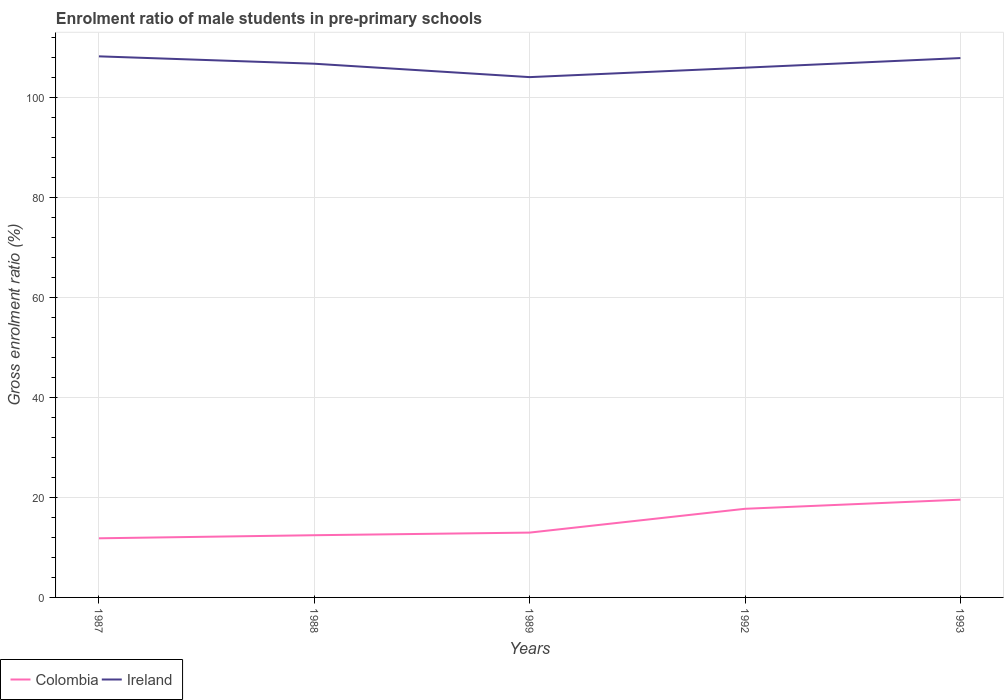How many different coloured lines are there?
Keep it short and to the point. 2. Does the line corresponding to Ireland intersect with the line corresponding to Colombia?
Keep it short and to the point. No. Is the number of lines equal to the number of legend labels?
Your answer should be compact. Yes. Across all years, what is the maximum enrolment ratio of male students in pre-primary schools in Ireland?
Provide a succinct answer. 103.99. What is the total enrolment ratio of male students in pre-primary schools in Ireland in the graph?
Offer a terse response. 2.68. What is the difference between the highest and the second highest enrolment ratio of male students in pre-primary schools in Ireland?
Make the answer very short. 4.15. What is the difference between the highest and the lowest enrolment ratio of male students in pre-primary schools in Ireland?
Ensure brevity in your answer.  3. Is the enrolment ratio of male students in pre-primary schools in Colombia strictly greater than the enrolment ratio of male students in pre-primary schools in Ireland over the years?
Offer a very short reply. Yes. How many lines are there?
Your answer should be compact. 2. Are the values on the major ticks of Y-axis written in scientific E-notation?
Give a very brief answer. No. How many legend labels are there?
Provide a succinct answer. 2. What is the title of the graph?
Your answer should be compact. Enrolment ratio of male students in pre-primary schools. What is the label or title of the Y-axis?
Keep it short and to the point. Gross enrolment ratio (%). What is the Gross enrolment ratio (%) of Colombia in 1987?
Keep it short and to the point. 11.82. What is the Gross enrolment ratio (%) in Ireland in 1987?
Offer a terse response. 108.15. What is the Gross enrolment ratio (%) in Colombia in 1988?
Your response must be concise. 12.43. What is the Gross enrolment ratio (%) of Ireland in 1988?
Provide a short and direct response. 106.67. What is the Gross enrolment ratio (%) in Colombia in 1989?
Provide a short and direct response. 12.96. What is the Gross enrolment ratio (%) of Ireland in 1989?
Make the answer very short. 103.99. What is the Gross enrolment ratio (%) in Colombia in 1992?
Keep it short and to the point. 17.72. What is the Gross enrolment ratio (%) in Ireland in 1992?
Make the answer very short. 105.88. What is the Gross enrolment ratio (%) of Colombia in 1993?
Your answer should be compact. 19.54. What is the Gross enrolment ratio (%) of Ireland in 1993?
Your answer should be very brief. 107.8. Across all years, what is the maximum Gross enrolment ratio (%) of Colombia?
Give a very brief answer. 19.54. Across all years, what is the maximum Gross enrolment ratio (%) in Ireland?
Make the answer very short. 108.15. Across all years, what is the minimum Gross enrolment ratio (%) in Colombia?
Offer a terse response. 11.82. Across all years, what is the minimum Gross enrolment ratio (%) of Ireland?
Provide a short and direct response. 103.99. What is the total Gross enrolment ratio (%) of Colombia in the graph?
Your response must be concise. 74.47. What is the total Gross enrolment ratio (%) in Ireland in the graph?
Your answer should be very brief. 532.5. What is the difference between the Gross enrolment ratio (%) of Colombia in 1987 and that in 1988?
Your answer should be very brief. -0.62. What is the difference between the Gross enrolment ratio (%) in Ireland in 1987 and that in 1988?
Give a very brief answer. 1.47. What is the difference between the Gross enrolment ratio (%) in Colombia in 1987 and that in 1989?
Your answer should be very brief. -1.14. What is the difference between the Gross enrolment ratio (%) of Ireland in 1987 and that in 1989?
Ensure brevity in your answer.  4.15. What is the difference between the Gross enrolment ratio (%) of Colombia in 1987 and that in 1992?
Make the answer very short. -5.9. What is the difference between the Gross enrolment ratio (%) of Ireland in 1987 and that in 1992?
Provide a short and direct response. 2.26. What is the difference between the Gross enrolment ratio (%) in Colombia in 1987 and that in 1993?
Provide a succinct answer. -7.72. What is the difference between the Gross enrolment ratio (%) of Ireland in 1987 and that in 1993?
Provide a short and direct response. 0.34. What is the difference between the Gross enrolment ratio (%) of Colombia in 1988 and that in 1989?
Your response must be concise. -0.52. What is the difference between the Gross enrolment ratio (%) of Ireland in 1988 and that in 1989?
Give a very brief answer. 2.68. What is the difference between the Gross enrolment ratio (%) in Colombia in 1988 and that in 1992?
Your answer should be compact. -5.28. What is the difference between the Gross enrolment ratio (%) in Ireland in 1988 and that in 1992?
Make the answer very short. 0.79. What is the difference between the Gross enrolment ratio (%) of Colombia in 1988 and that in 1993?
Keep it short and to the point. -7.1. What is the difference between the Gross enrolment ratio (%) in Ireland in 1988 and that in 1993?
Provide a succinct answer. -1.13. What is the difference between the Gross enrolment ratio (%) of Colombia in 1989 and that in 1992?
Provide a succinct answer. -4.76. What is the difference between the Gross enrolment ratio (%) of Ireland in 1989 and that in 1992?
Your answer should be compact. -1.89. What is the difference between the Gross enrolment ratio (%) of Colombia in 1989 and that in 1993?
Your answer should be very brief. -6.58. What is the difference between the Gross enrolment ratio (%) of Ireland in 1989 and that in 1993?
Give a very brief answer. -3.81. What is the difference between the Gross enrolment ratio (%) in Colombia in 1992 and that in 1993?
Offer a terse response. -1.82. What is the difference between the Gross enrolment ratio (%) of Ireland in 1992 and that in 1993?
Offer a terse response. -1.92. What is the difference between the Gross enrolment ratio (%) in Colombia in 1987 and the Gross enrolment ratio (%) in Ireland in 1988?
Give a very brief answer. -94.85. What is the difference between the Gross enrolment ratio (%) in Colombia in 1987 and the Gross enrolment ratio (%) in Ireland in 1989?
Keep it short and to the point. -92.18. What is the difference between the Gross enrolment ratio (%) in Colombia in 1987 and the Gross enrolment ratio (%) in Ireland in 1992?
Offer a very short reply. -94.06. What is the difference between the Gross enrolment ratio (%) of Colombia in 1987 and the Gross enrolment ratio (%) of Ireland in 1993?
Your response must be concise. -95.99. What is the difference between the Gross enrolment ratio (%) in Colombia in 1988 and the Gross enrolment ratio (%) in Ireland in 1989?
Provide a succinct answer. -91.56. What is the difference between the Gross enrolment ratio (%) in Colombia in 1988 and the Gross enrolment ratio (%) in Ireland in 1992?
Offer a terse response. -93.45. What is the difference between the Gross enrolment ratio (%) of Colombia in 1988 and the Gross enrolment ratio (%) of Ireland in 1993?
Offer a terse response. -95.37. What is the difference between the Gross enrolment ratio (%) of Colombia in 1989 and the Gross enrolment ratio (%) of Ireland in 1992?
Make the answer very short. -92.92. What is the difference between the Gross enrolment ratio (%) of Colombia in 1989 and the Gross enrolment ratio (%) of Ireland in 1993?
Offer a terse response. -94.85. What is the difference between the Gross enrolment ratio (%) in Colombia in 1992 and the Gross enrolment ratio (%) in Ireland in 1993?
Your answer should be very brief. -90.09. What is the average Gross enrolment ratio (%) of Colombia per year?
Offer a terse response. 14.89. What is the average Gross enrolment ratio (%) of Ireland per year?
Give a very brief answer. 106.5. In the year 1987, what is the difference between the Gross enrolment ratio (%) in Colombia and Gross enrolment ratio (%) in Ireland?
Provide a succinct answer. -96.33. In the year 1988, what is the difference between the Gross enrolment ratio (%) of Colombia and Gross enrolment ratio (%) of Ireland?
Your answer should be compact. -94.24. In the year 1989, what is the difference between the Gross enrolment ratio (%) of Colombia and Gross enrolment ratio (%) of Ireland?
Give a very brief answer. -91.04. In the year 1992, what is the difference between the Gross enrolment ratio (%) of Colombia and Gross enrolment ratio (%) of Ireland?
Your answer should be very brief. -88.16. In the year 1993, what is the difference between the Gross enrolment ratio (%) of Colombia and Gross enrolment ratio (%) of Ireland?
Offer a very short reply. -88.26. What is the ratio of the Gross enrolment ratio (%) in Colombia in 1987 to that in 1988?
Offer a very short reply. 0.95. What is the ratio of the Gross enrolment ratio (%) of Ireland in 1987 to that in 1988?
Offer a terse response. 1.01. What is the ratio of the Gross enrolment ratio (%) of Colombia in 1987 to that in 1989?
Ensure brevity in your answer.  0.91. What is the ratio of the Gross enrolment ratio (%) in Ireland in 1987 to that in 1989?
Your answer should be compact. 1.04. What is the ratio of the Gross enrolment ratio (%) in Colombia in 1987 to that in 1992?
Your response must be concise. 0.67. What is the ratio of the Gross enrolment ratio (%) of Ireland in 1987 to that in 1992?
Ensure brevity in your answer.  1.02. What is the ratio of the Gross enrolment ratio (%) in Colombia in 1987 to that in 1993?
Give a very brief answer. 0.6. What is the ratio of the Gross enrolment ratio (%) of Colombia in 1988 to that in 1989?
Make the answer very short. 0.96. What is the ratio of the Gross enrolment ratio (%) in Ireland in 1988 to that in 1989?
Ensure brevity in your answer.  1.03. What is the ratio of the Gross enrolment ratio (%) of Colombia in 1988 to that in 1992?
Make the answer very short. 0.7. What is the ratio of the Gross enrolment ratio (%) of Ireland in 1988 to that in 1992?
Ensure brevity in your answer.  1.01. What is the ratio of the Gross enrolment ratio (%) of Colombia in 1988 to that in 1993?
Ensure brevity in your answer.  0.64. What is the ratio of the Gross enrolment ratio (%) of Ireland in 1988 to that in 1993?
Provide a succinct answer. 0.99. What is the ratio of the Gross enrolment ratio (%) of Colombia in 1989 to that in 1992?
Ensure brevity in your answer.  0.73. What is the ratio of the Gross enrolment ratio (%) in Ireland in 1989 to that in 1992?
Your answer should be very brief. 0.98. What is the ratio of the Gross enrolment ratio (%) in Colombia in 1989 to that in 1993?
Keep it short and to the point. 0.66. What is the ratio of the Gross enrolment ratio (%) in Ireland in 1989 to that in 1993?
Provide a short and direct response. 0.96. What is the ratio of the Gross enrolment ratio (%) of Colombia in 1992 to that in 1993?
Ensure brevity in your answer.  0.91. What is the ratio of the Gross enrolment ratio (%) in Ireland in 1992 to that in 1993?
Provide a succinct answer. 0.98. What is the difference between the highest and the second highest Gross enrolment ratio (%) in Colombia?
Ensure brevity in your answer.  1.82. What is the difference between the highest and the second highest Gross enrolment ratio (%) in Ireland?
Your response must be concise. 0.34. What is the difference between the highest and the lowest Gross enrolment ratio (%) of Colombia?
Your response must be concise. 7.72. What is the difference between the highest and the lowest Gross enrolment ratio (%) in Ireland?
Offer a very short reply. 4.15. 